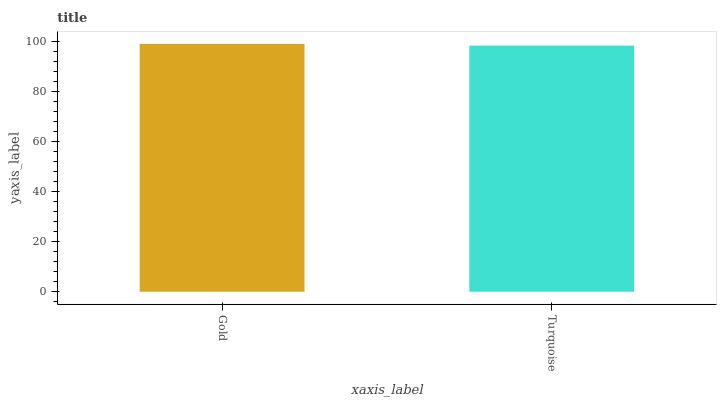Is Turquoise the minimum?
Answer yes or no. Yes. Is Gold the maximum?
Answer yes or no. Yes. Is Turquoise the maximum?
Answer yes or no. No. Is Gold greater than Turquoise?
Answer yes or no. Yes. Is Turquoise less than Gold?
Answer yes or no. Yes. Is Turquoise greater than Gold?
Answer yes or no. No. Is Gold less than Turquoise?
Answer yes or no. No. Is Gold the high median?
Answer yes or no. Yes. Is Turquoise the low median?
Answer yes or no. Yes. Is Turquoise the high median?
Answer yes or no. No. Is Gold the low median?
Answer yes or no. No. 